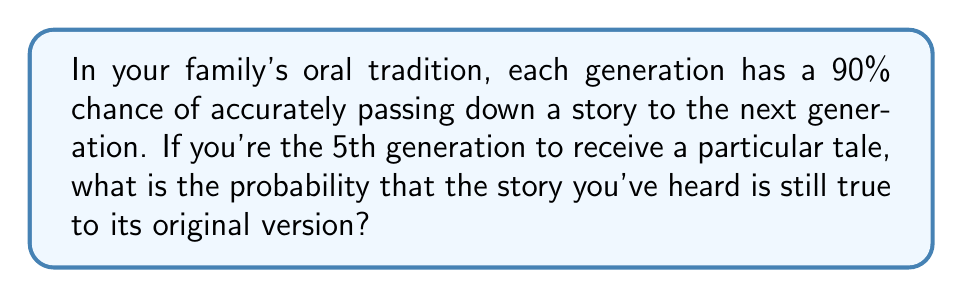Could you help me with this problem? Let's approach this step-by-step:

1) The probability of the story being accurately passed down from one generation to the next is 90% or 0.9.

2) For the story to reach you in its original form, it needs to be accurately passed down through all 4 previous generations.

3) The probability of independent events occurring together is the product of their individual probabilities.

4) Therefore, we need to calculate $0.9^4$, as the story needs to be accurately passed down 4 times.

5) Let's calculate:

   $$0.9^4 = 0.9 \times 0.9 \times 0.9 \times 0.9 = 0.6561$$

6) Converting to a percentage:

   $$0.6561 \times 100\% = 65.61\%$$

Thus, there is approximately a 65.61% chance that the story you've heard is still true to its original version.
Answer: 65.61% 